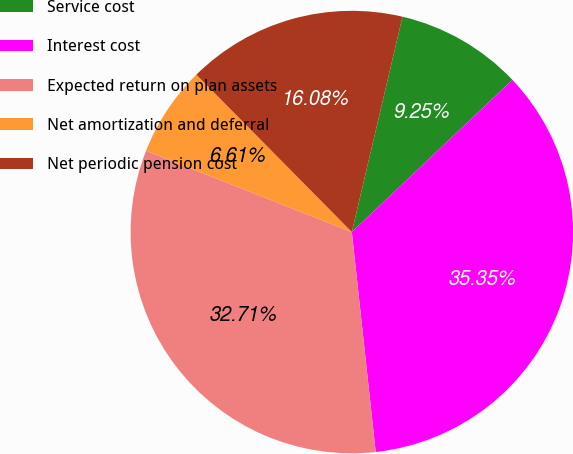Convert chart. <chart><loc_0><loc_0><loc_500><loc_500><pie_chart><fcel>Service cost<fcel>Interest cost<fcel>Expected return on plan assets<fcel>Net amortization and deferral<fcel>Net periodic pension cost<nl><fcel>9.25%<fcel>35.35%<fcel>32.71%<fcel>6.61%<fcel>16.08%<nl></chart> 